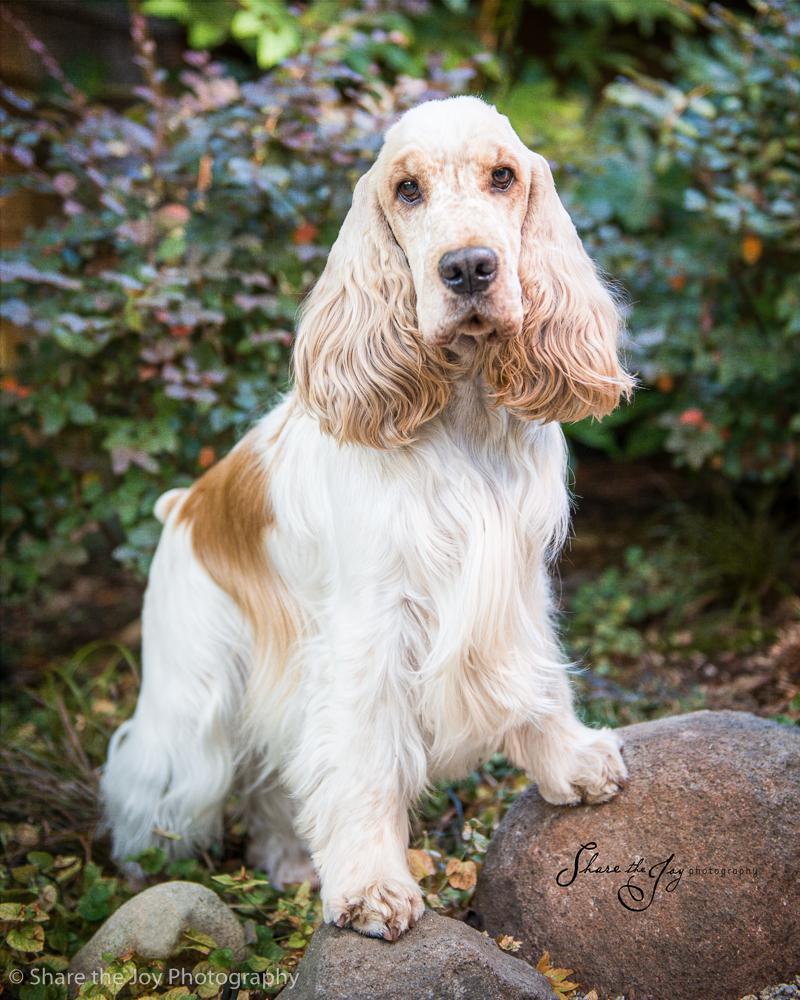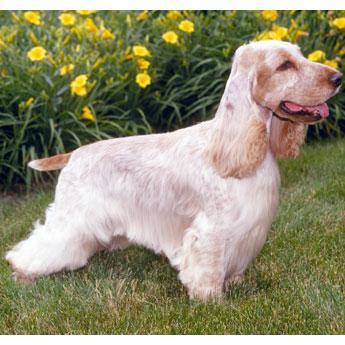The first image is the image on the left, the second image is the image on the right. Analyze the images presented: Is the assertion "The right photo shows a dog standing in the grass." valid? Answer yes or no. Yes. The first image is the image on the left, the second image is the image on the right. Evaluate the accuracy of this statement regarding the images: "There are two dogs shown in total". Is it true? Answer yes or no. Yes. 